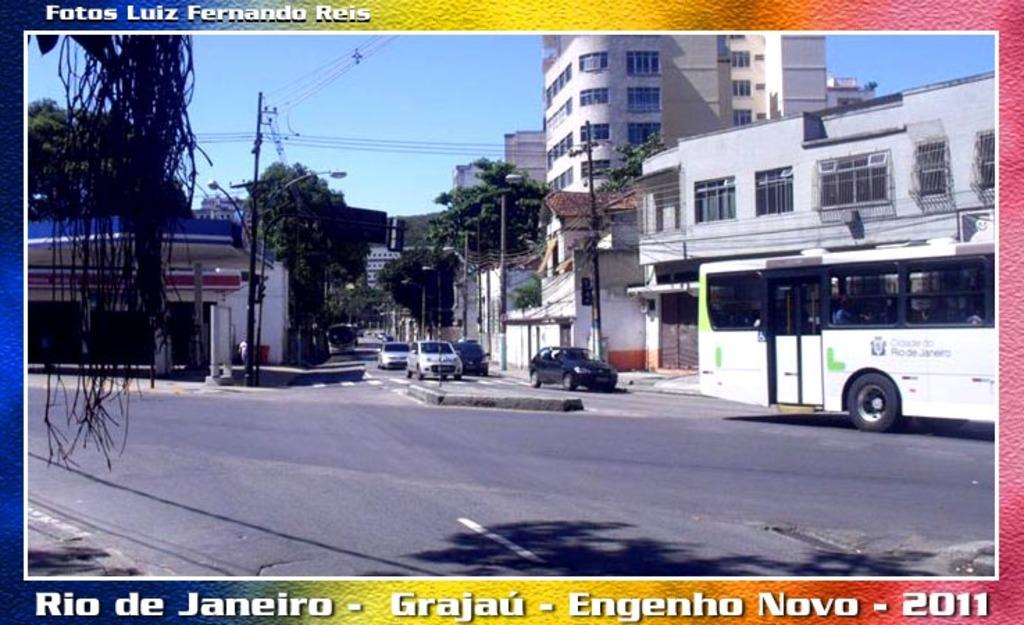<image>
Present a compact description of the photo's key features. A photograph of a street in Rio De Janeiro in the year 2011. 